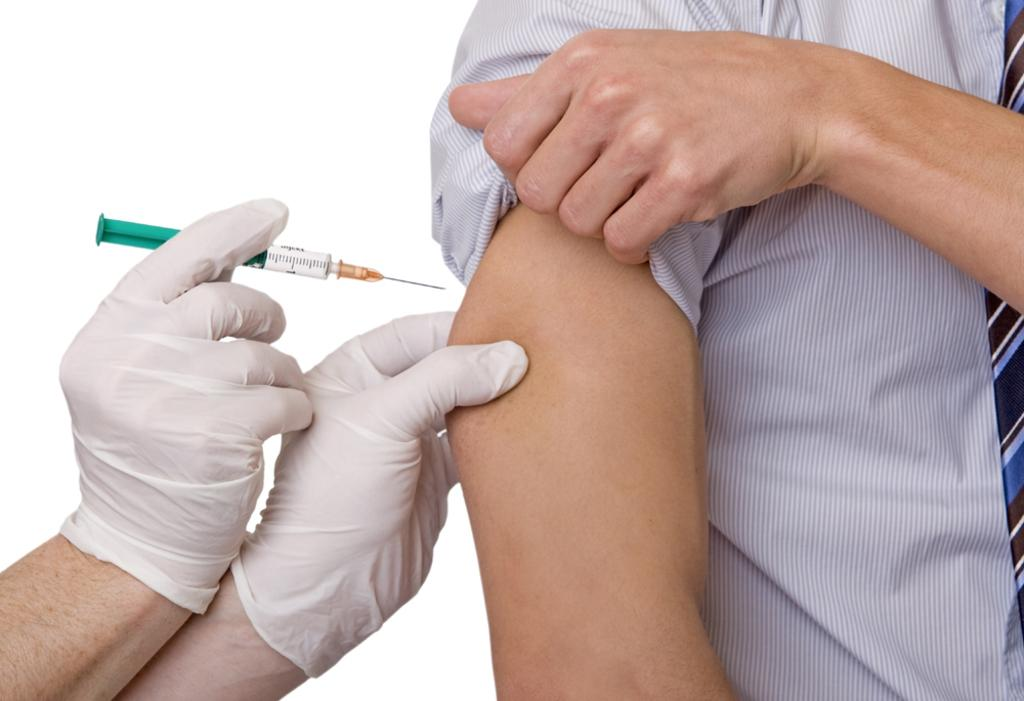What is the hand holding in the image? The hand is holding a syringe in the image. What is the relationship between the hand and the man in the image? The man is receiving an injection on his hand. Can you describe the appearance of the hand in the image? The hand is wearing gloves. What rule is being enforced by the crowd in the image? There is no crowd present in the image, and therefore no rule enforcement can be observed. What type of iron is visible in the image? There is no iron present in the image. 